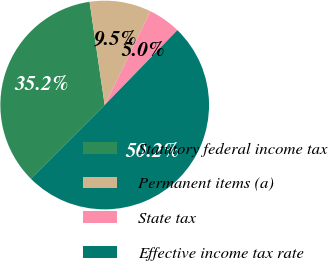Convert chart to OTSL. <chart><loc_0><loc_0><loc_500><loc_500><pie_chart><fcel>Statutory federal income tax<fcel>Permanent items (a)<fcel>State tax<fcel>Effective income tax rate<nl><fcel>35.18%<fcel>9.55%<fcel>5.03%<fcel>50.25%<nl></chart> 